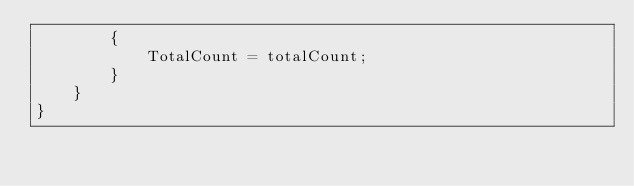Convert code to text. <code><loc_0><loc_0><loc_500><loc_500><_C#_>        {
            TotalCount = totalCount;
        }
    }
}</code> 